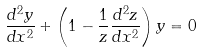Convert formula to latex. <formula><loc_0><loc_0><loc_500><loc_500>\frac { d ^ { 2 } y } { d x ^ { 2 } } + \left ( 1 - \frac { 1 } { z } \frac { d ^ { 2 } z } { d x ^ { 2 } } \right ) y = 0</formula> 